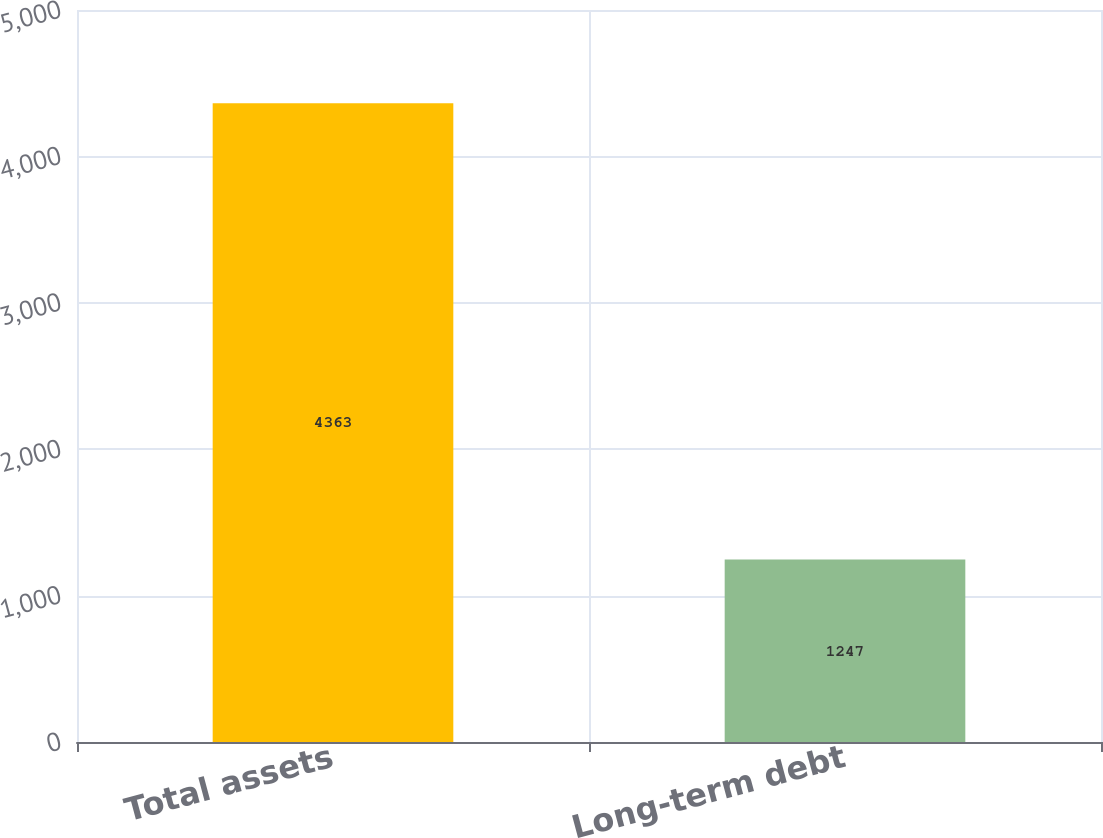Convert chart. <chart><loc_0><loc_0><loc_500><loc_500><bar_chart><fcel>Total assets<fcel>Long-term debt<nl><fcel>4363<fcel>1247<nl></chart> 